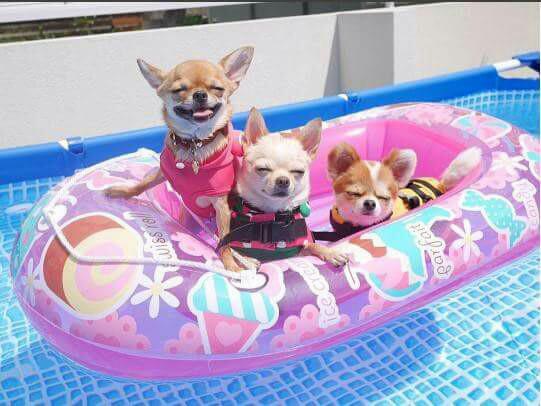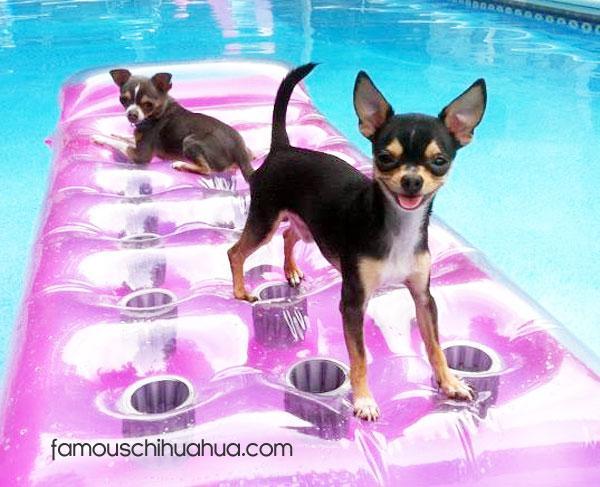The first image is the image on the left, the second image is the image on the right. Given the left and right images, does the statement "In one image, a small dog is standing in a kids' plastic pool, while the second image shows a similar dog in a large inground swimming pool, either in or near a floatation device." hold true? Answer yes or no. No. The first image is the image on the left, the second image is the image on the right. Examine the images to the left and right. Is the description "A single dog is standing up inside a kiddie pool, in one image." accurate? Answer yes or no. No. 